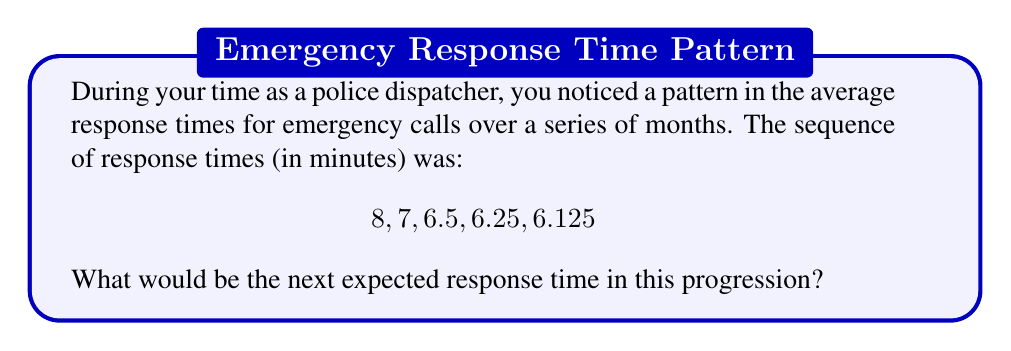Could you help me with this problem? To solve this problem, let's analyze the pattern in the given sequence:

1) First, calculate the differences between consecutive terms:
   8 - 7 = 1
   7 - 6.5 = 0.5
   6.5 - 6.25 = 0.25
   6.25 - 6.125 = 0.125

2) We can observe that each difference is half of the previous difference:
   1 ÷ 2 = 0.5
   0.5 ÷ 2 = 0.25
   0.25 ÷ 2 = 0.125

3) Following this pattern, the next difference would be:
   0.125 ÷ 2 = 0.0625

4) To find the next term in the original sequence, we subtract this new difference from the last given term:
   6.125 - 0.0625 = 6.0625

Therefore, the next expected response time in this progression would be 6.0625 minutes.

This pattern can be expressed mathematically as:

$$a_n = a_1 - \sum_{i=1}^{n-1} \frac{1}{2^i}$$

Where $a_n$ is the nth term in the sequence, and $a_1$ is the first term (8 in this case).
Answer: 6.0625 